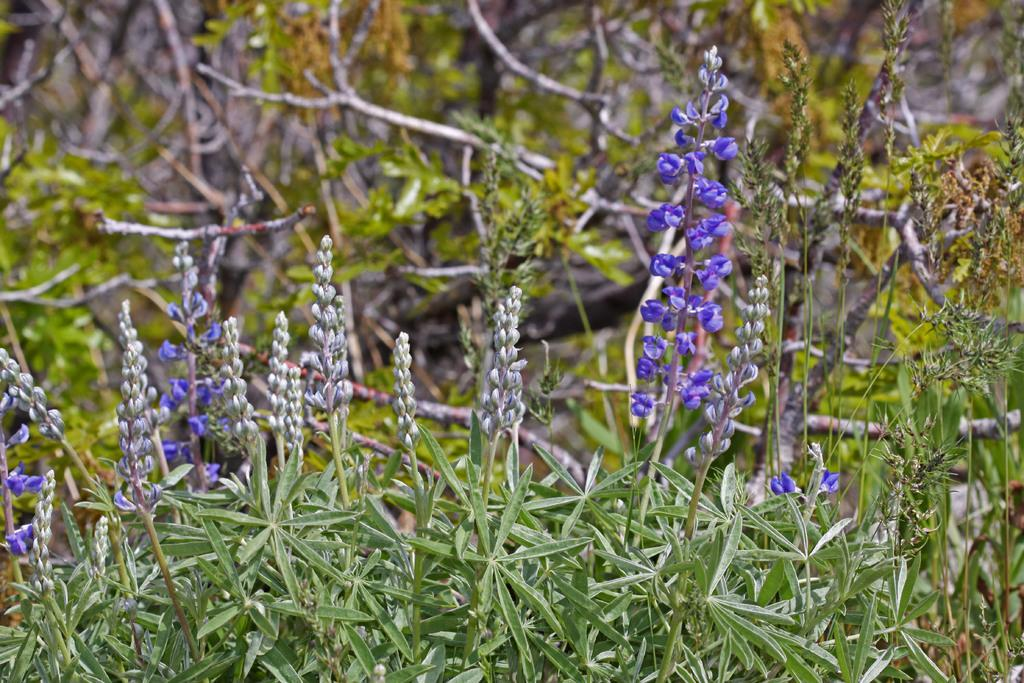What type of living organisms can be seen in the image? Plants can be seen in the image. What color are the flowers on the plants? The flowers on the plants have a violet color. What can be seen in the background of the image? There are trees in the background of the image. What type of pets are visible in the image? There are no pets visible in the image; it features plants with violet flowers and trees in the background. What type of vessel is being used to water the plants in the image? There is no vessel present in the image, as it only shows plants with violet flowers and trees in the background. 